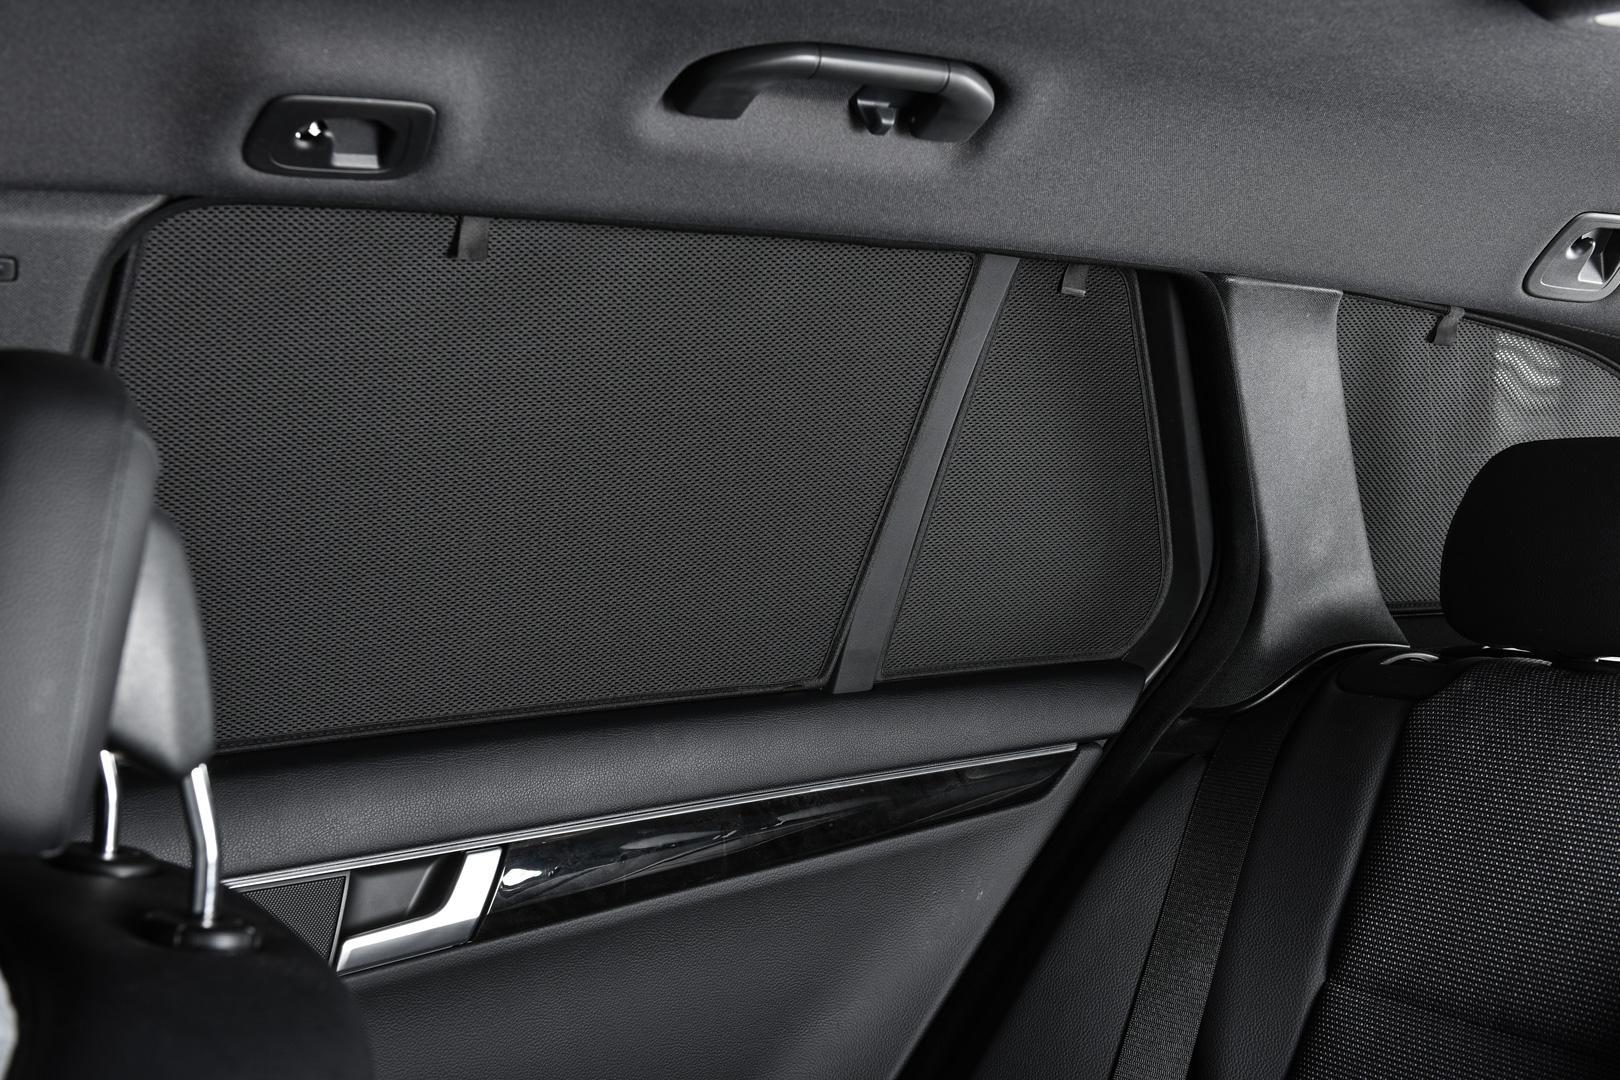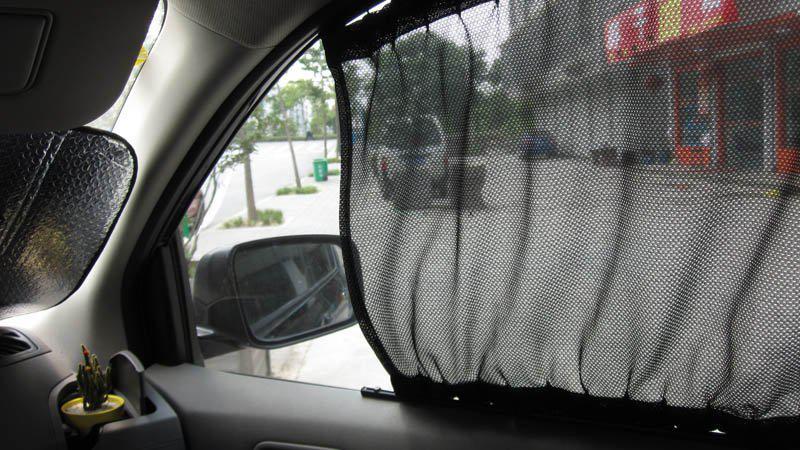The first image is the image on the left, the second image is the image on the right. Given the left and right images, does the statement "A human arm is visible on the right image." hold true? Answer yes or no. No. 